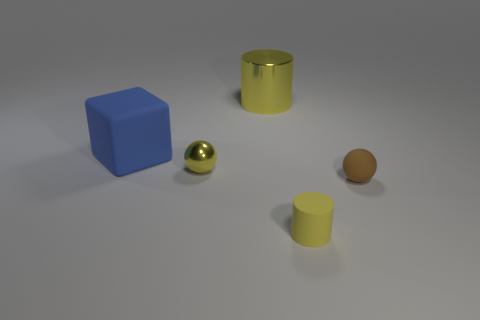How many other things are there of the same color as the matte cylinder?
Offer a terse response. 2. Are there more blue blocks that are behind the large blue object than brown objects left of the brown matte sphere?
Your answer should be very brief. No. Is there any other thing that has the same size as the matte cylinder?
Give a very brief answer. Yes. What number of blocks are tiny gray matte things or blue objects?
Your answer should be very brief. 1. How many objects are either yellow things behind the matte ball or big purple shiny cylinders?
Provide a short and direct response. 2. The tiny yellow thing that is to the right of the yellow sphere that is on the left side of the yellow thing that is in front of the brown matte sphere is what shape?
Offer a very short reply. Cylinder. What number of other things are the same shape as the small yellow metallic thing?
Provide a short and direct response. 1. There is another big cylinder that is the same color as the matte cylinder; what is it made of?
Your answer should be compact. Metal. Are the big blue thing and the tiny yellow ball made of the same material?
Make the answer very short. No. What number of large yellow metal objects are right of the metallic thing behind the matte object that is behind the tiny yellow shiny ball?
Your answer should be very brief. 0. 